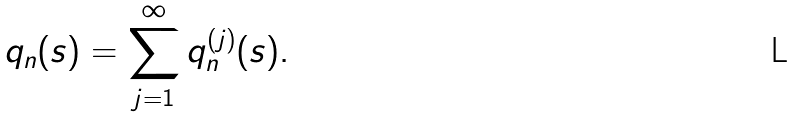Convert formula to latex. <formula><loc_0><loc_0><loc_500><loc_500>q _ { n } ( s ) = \sum _ { j = 1 } ^ { \infty } q _ { n } ^ { ( j ) } ( s ) .</formula> 